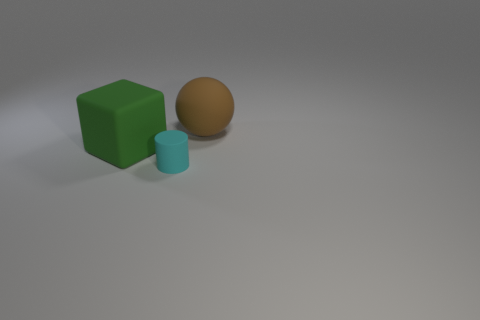Add 3 big green metallic balls. How many objects exist? 6 Subtract all cubes. How many objects are left? 2 Subtract all purple spheres. How many yellow cubes are left? 0 Subtract all small yellow rubber blocks. Subtract all cyan cylinders. How many objects are left? 2 Add 3 small cylinders. How many small cylinders are left? 4 Add 3 cubes. How many cubes exist? 4 Subtract 0 gray blocks. How many objects are left? 3 Subtract all yellow cylinders. Subtract all green cubes. How many cylinders are left? 1 